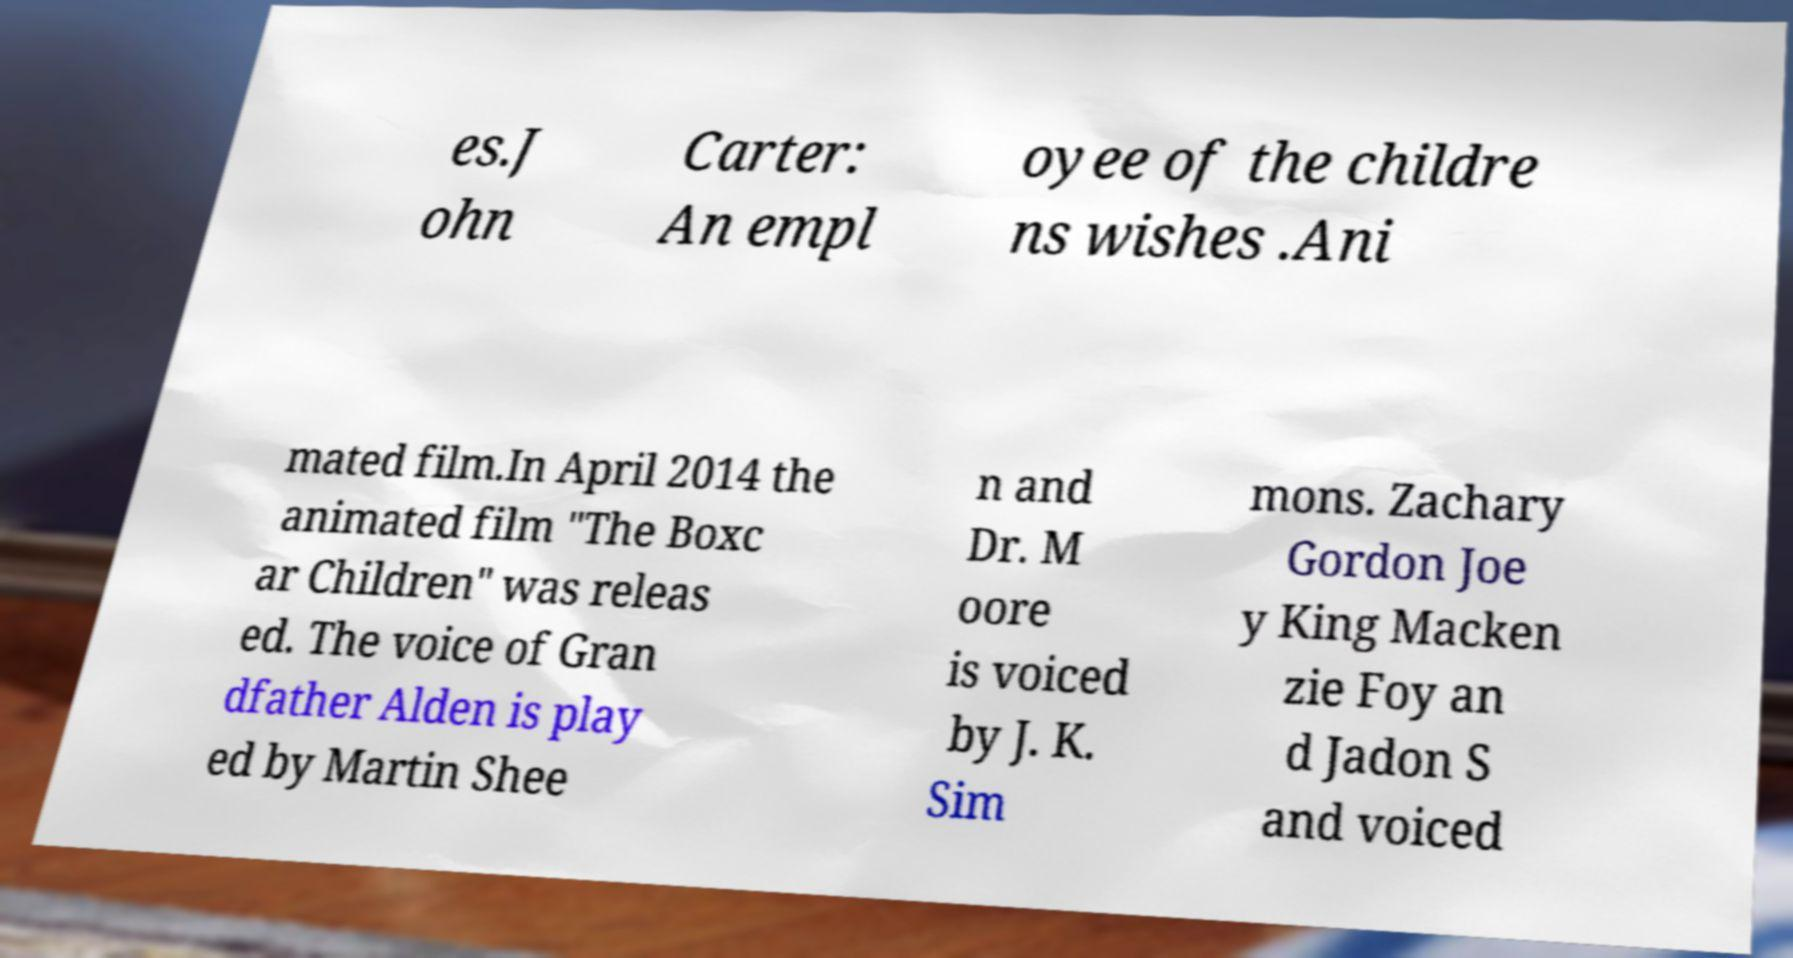Could you assist in decoding the text presented in this image and type it out clearly? es.J ohn Carter: An empl oyee of the childre ns wishes .Ani mated film.In April 2014 the animated film "The Boxc ar Children" was releas ed. The voice of Gran dfather Alden is play ed by Martin Shee n and Dr. M oore is voiced by J. K. Sim mons. Zachary Gordon Joe y King Macken zie Foy an d Jadon S and voiced 